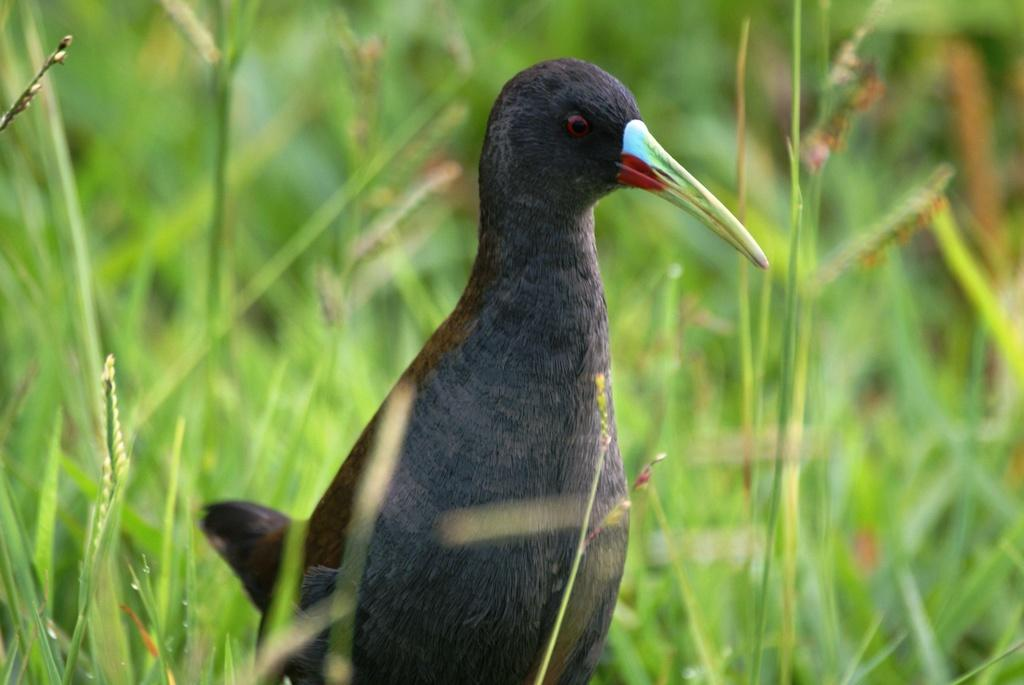What type of bird can be seen in the image? There is a black color bird in the image. In which direction is the bird looking? The bird is looking to the right side. What type of vegetation is visible in the image? There is grass visible in the image. What substance is the bird cooking in the image? There is no indication in the image that the bird is cooking or interacting with any substance. 